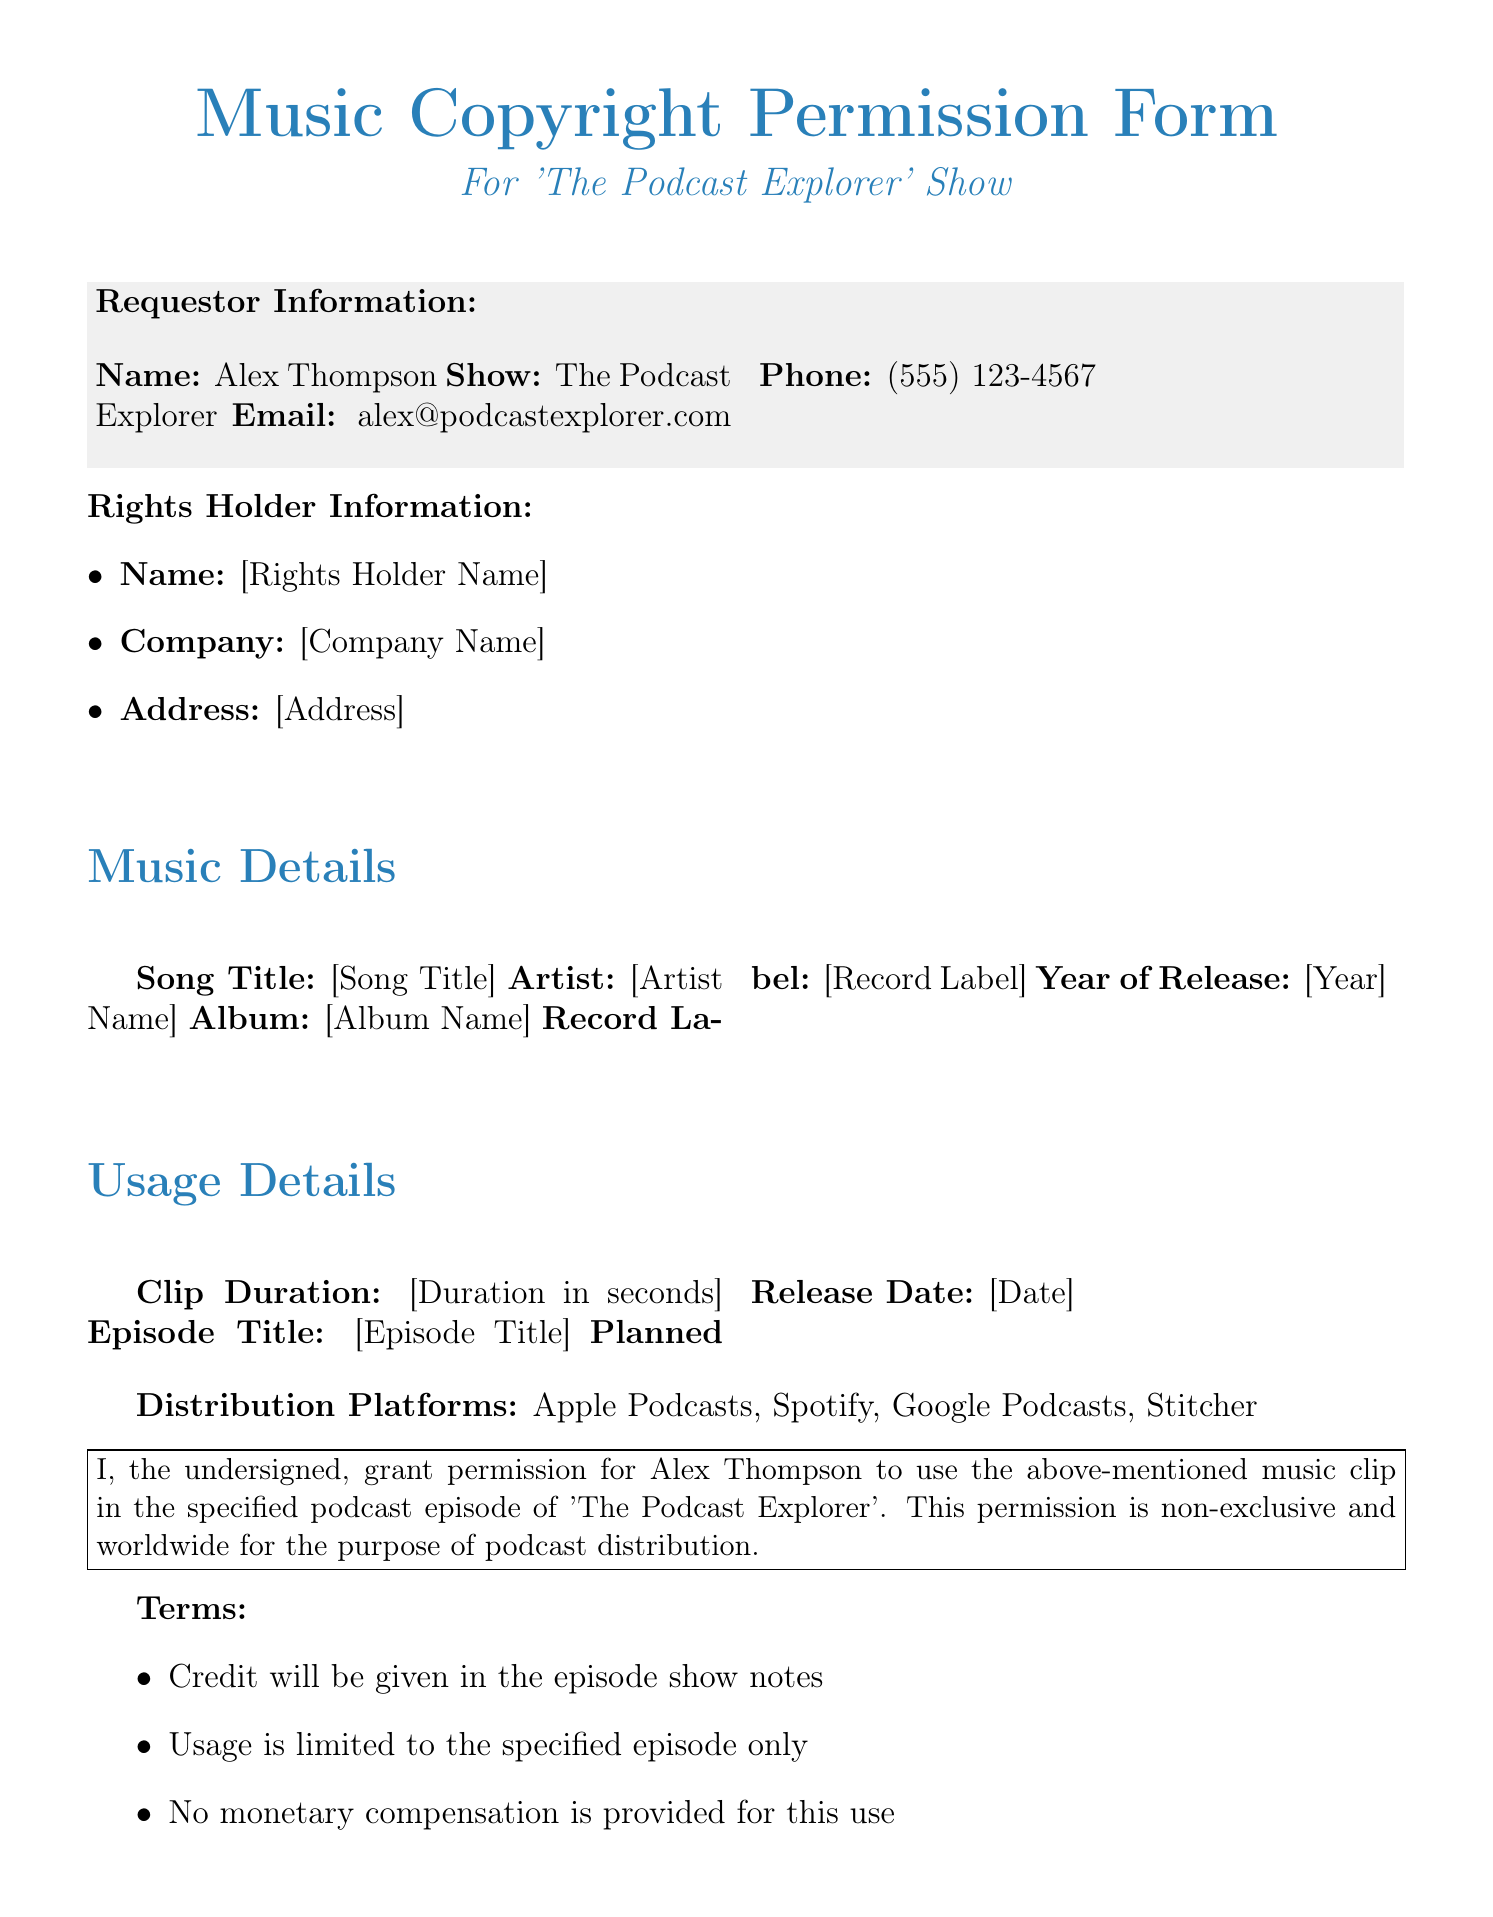What is the name of the requestor? The requestor's name is listed in the "Requestor Information" section of the document.
Answer: Alex Thompson What is the email address of the requestor? The email address is provided in the "Requestor Information" section.
Answer: alex@podcastexplorer.com What is the planned release date of the podcast episode? The planned release date is specified under the "Usage Details" section.
Answer: [Date] Who is the artist of the song? The artist's name can be found in the "Music Details" section of the document.
Answer: [Artist Name] What is the clip duration requested? This information is contained in the "Usage Details" section.
Answer: [Duration in seconds] What is the purpose of granting permission in this document? The permission states the reason for its granting in the text block of the document.
Answer: podcast distribution What type of permission is granted in this form? The document specifies the nature of the permission granted.
Answer: non-exclusive What are the distribution platforms mentioned? The platforms are listed in the "Usage Details" section.
Answer: Apple Podcasts, Spotify, Google Podcasts, Stitcher What is the required action after signing the form? The document instructs the signer on the next steps after signing.
Answer: return this form via fax or email 